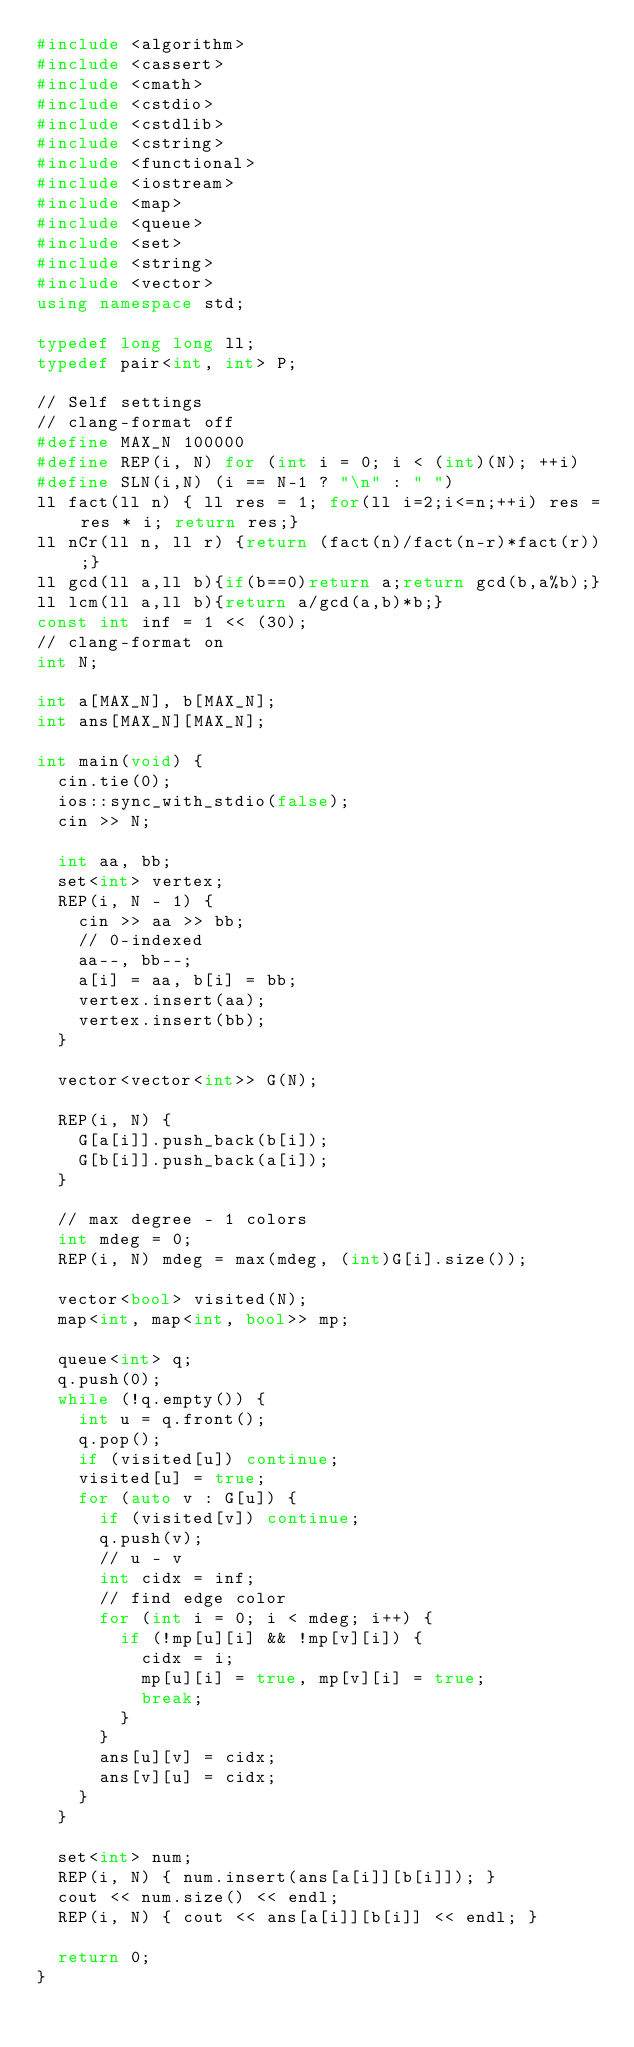Convert code to text. <code><loc_0><loc_0><loc_500><loc_500><_C++_>#include <algorithm>
#include <cassert>
#include <cmath>
#include <cstdio>
#include <cstdlib>
#include <cstring>
#include <functional>
#include <iostream>
#include <map>
#include <queue>
#include <set>
#include <string>
#include <vector>
using namespace std;

typedef long long ll;
typedef pair<int, int> P;

// Self settings
// clang-format off
#define MAX_N 100000
#define REP(i, N) for (int i = 0; i < (int)(N); ++i)
#define SLN(i,N) (i == N-1 ? "\n" : " ")
ll fact(ll n) { ll res = 1; for(ll i=2;i<=n;++i) res = res * i; return res;}
ll nCr(ll n, ll r) {return (fact(n)/fact(n-r)*fact(r)) ;}
ll gcd(ll a,ll b){if(b==0)return a;return gcd(b,a%b);}
ll lcm(ll a,ll b){return a/gcd(a,b)*b;}
const int inf = 1 << (30);
// clang-format on
int N;

int a[MAX_N], b[MAX_N];
int ans[MAX_N][MAX_N];

int main(void) {
  cin.tie(0);
  ios::sync_with_stdio(false);
  cin >> N;

  int aa, bb;
  set<int> vertex;
  REP(i, N - 1) {
    cin >> aa >> bb;
    // 0-indexed
    aa--, bb--;
    a[i] = aa, b[i] = bb;
    vertex.insert(aa);
    vertex.insert(bb);
  }

  vector<vector<int>> G(N);

  REP(i, N) {
    G[a[i]].push_back(b[i]);
    G[b[i]].push_back(a[i]);
  }

  // max degree - 1 colors
  int mdeg = 0;
  REP(i, N) mdeg = max(mdeg, (int)G[i].size());

  vector<bool> visited(N);
  map<int, map<int, bool>> mp;

  queue<int> q;
  q.push(0);
  while (!q.empty()) {
    int u = q.front();
    q.pop();
    if (visited[u]) continue;
    visited[u] = true;
    for (auto v : G[u]) {
      if (visited[v]) continue;
      q.push(v);
      // u - v
      int cidx = inf;
      // find edge color
      for (int i = 0; i < mdeg; i++) {
        if (!mp[u][i] && !mp[v][i]) {
          cidx = i;
          mp[u][i] = true, mp[v][i] = true;
          break;
        }
      }
      ans[u][v] = cidx;
      ans[v][u] = cidx;
    }
  }

  set<int> num;
  REP(i, N) { num.insert(ans[a[i]][b[i]]); }
  cout << num.size() << endl;
  REP(i, N) { cout << ans[a[i]][b[i]] << endl; }

  return 0;
}
</code> 